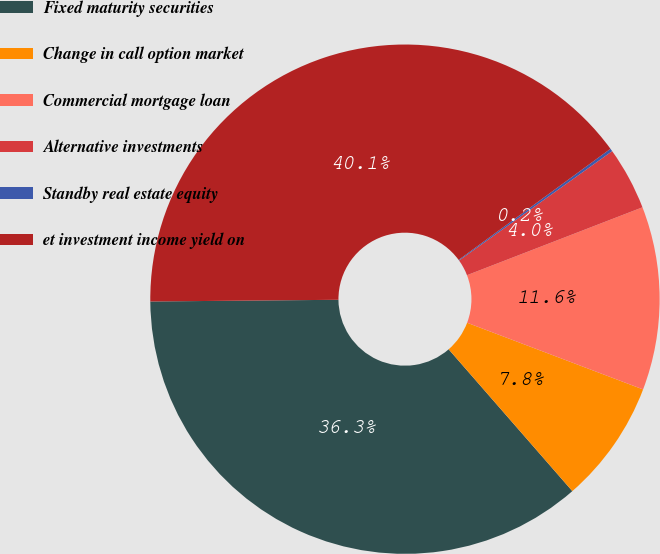<chart> <loc_0><loc_0><loc_500><loc_500><pie_chart><fcel>Fixed maturity securities<fcel>Change in call option market<fcel>Commercial mortgage loan<fcel>Alternative investments<fcel>Standby real estate equity<fcel>et investment income yield on<nl><fcel>36.27%<fcel>7.82%<fcel>11.64%<fcel>4.0%<fcel>0.18%<fcel>40.09%<nl></chart> 